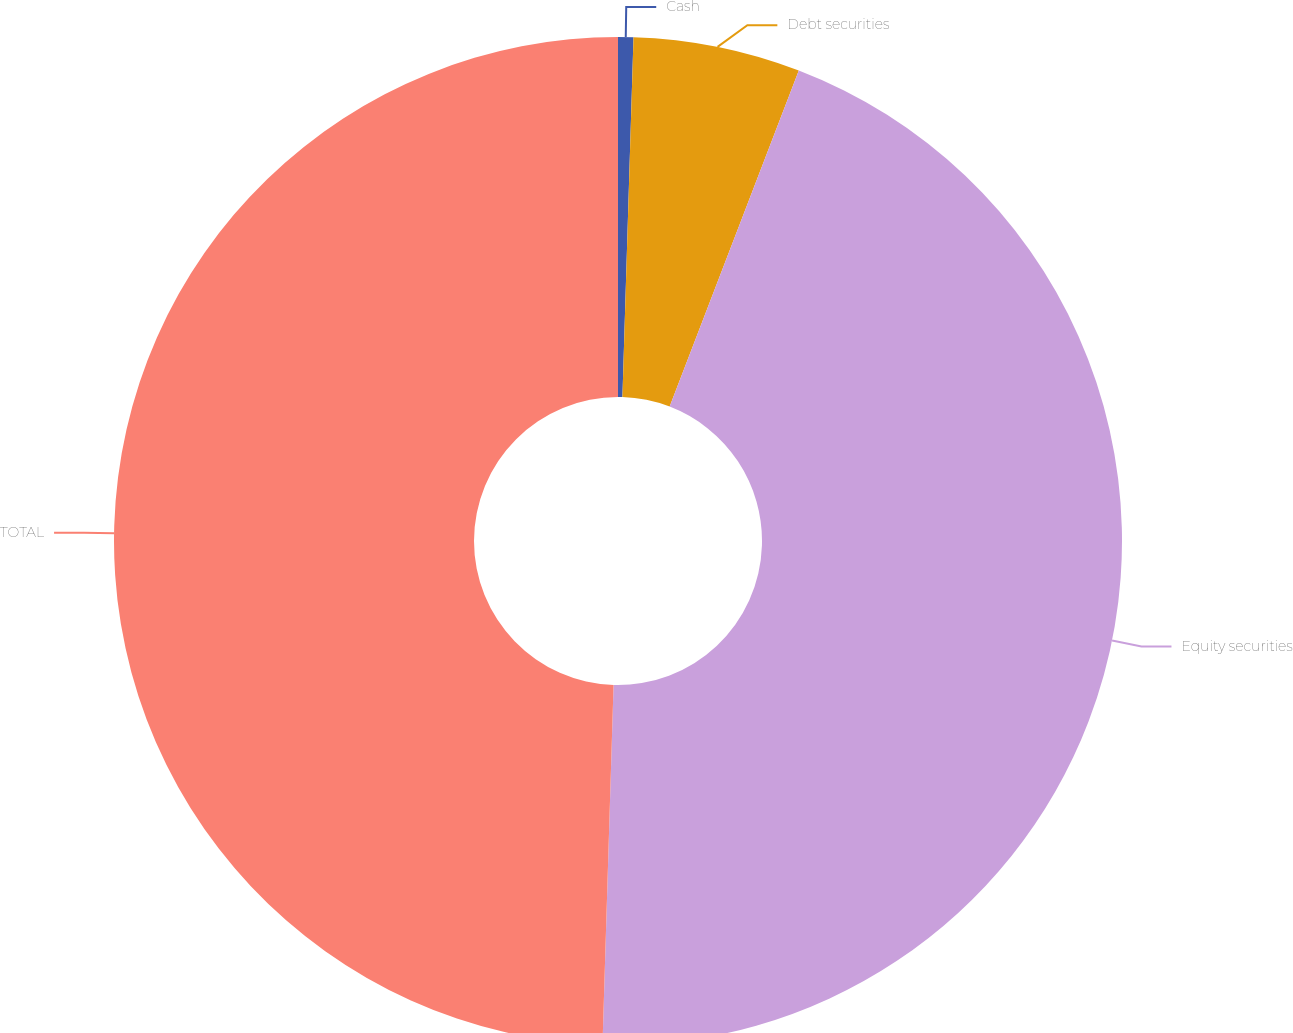Convert chart. <chart><loc_0><loc_0><loc_500><loc_500><pie_chart><fcel>Cash<fcel>Debt securities<fcel>Equity securities<fcel>TOTAL<nl><fcel>0.49%<fcel>5.35%<fcel>44.65%<fcel>49.51%<nl></chart> 